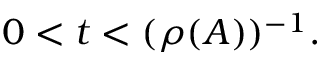Convert formula to latex. <formula><loc_0><loc_0><loc_500><loc_500>0 < t < ( \rho ( A ) ) ^ { - 1 } .</formula> 